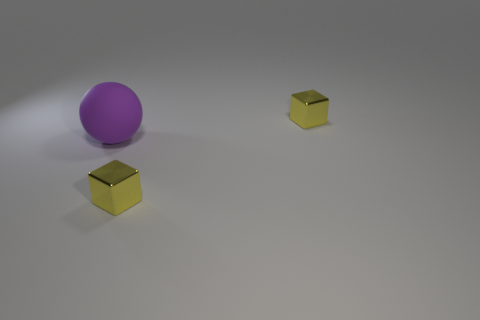What could be the possible size comparison between the purple ball and the golden cubes? Based on the image, the purple ball appears to be larger than the golden cubes. The exact size difference can't be determined without known measurements, but visually the ball's diameter seems to be roughly three to four times the length of a side of a cube. 